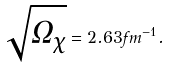Convert formula to latex. <formula><loc_0><loc_0><loc_500><loc_500>\sqrt { \Omega _ { \chi } } = 2 . 6 3 f m ^ { - 1 } .</formula> 